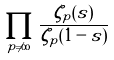Convert formula to latex. <formula><loc_0><loc_0><loc_500><loc_500>\prod _ { p \neq \infty } \frac { \zeta _ { p } ( s ) } { \zeta _ { p } ( 1 - s ) }</formula> 